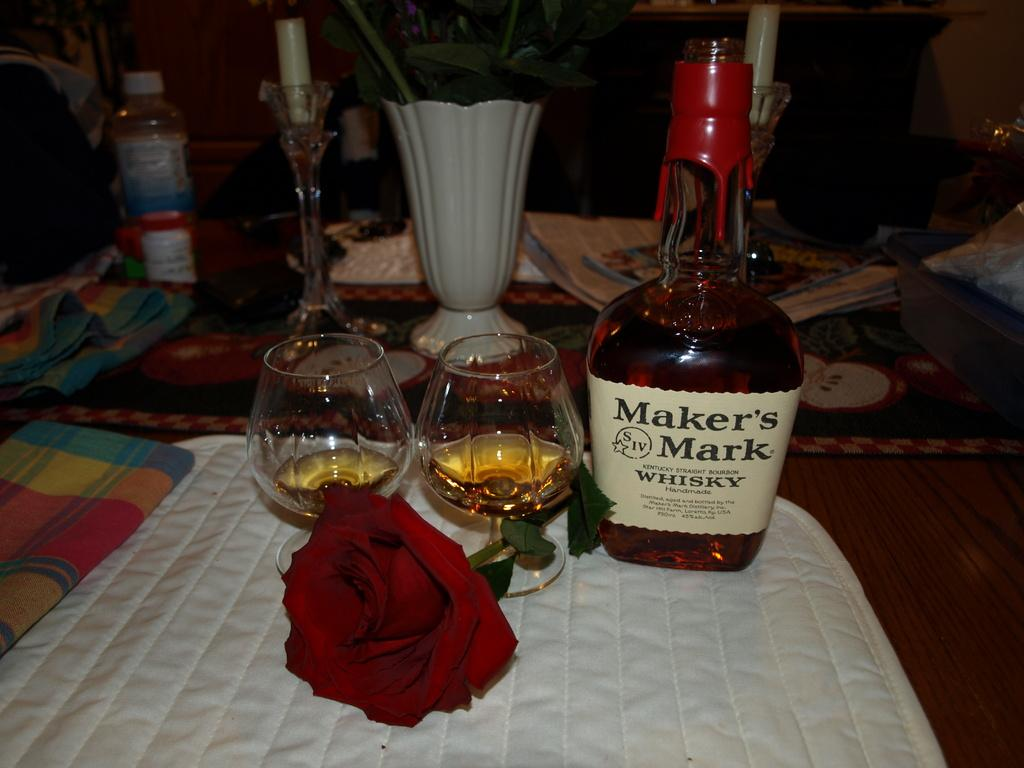What type of furniture is present in the image? There is a table in the image. What items are placed on the table? There are wine glasses, a wine bottle, and a rose plant flower on the table. What type of committee is meeting in the library, as depicted in the image? There is no committee or library present in the image; it only features a table with wine glasses, a wine bottle, and a rose plant flower. What color is the sock on the table in the image? There is no sock present in the image. 